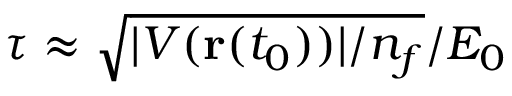Convert formula to latex. <formula><loc_0><loc_0><loc_500><loc_500>\tau \approx \sqrt { | V ( r ( t _ { 0 } ) ) | / n _ { f } } / E _ { 0 }</formula> 